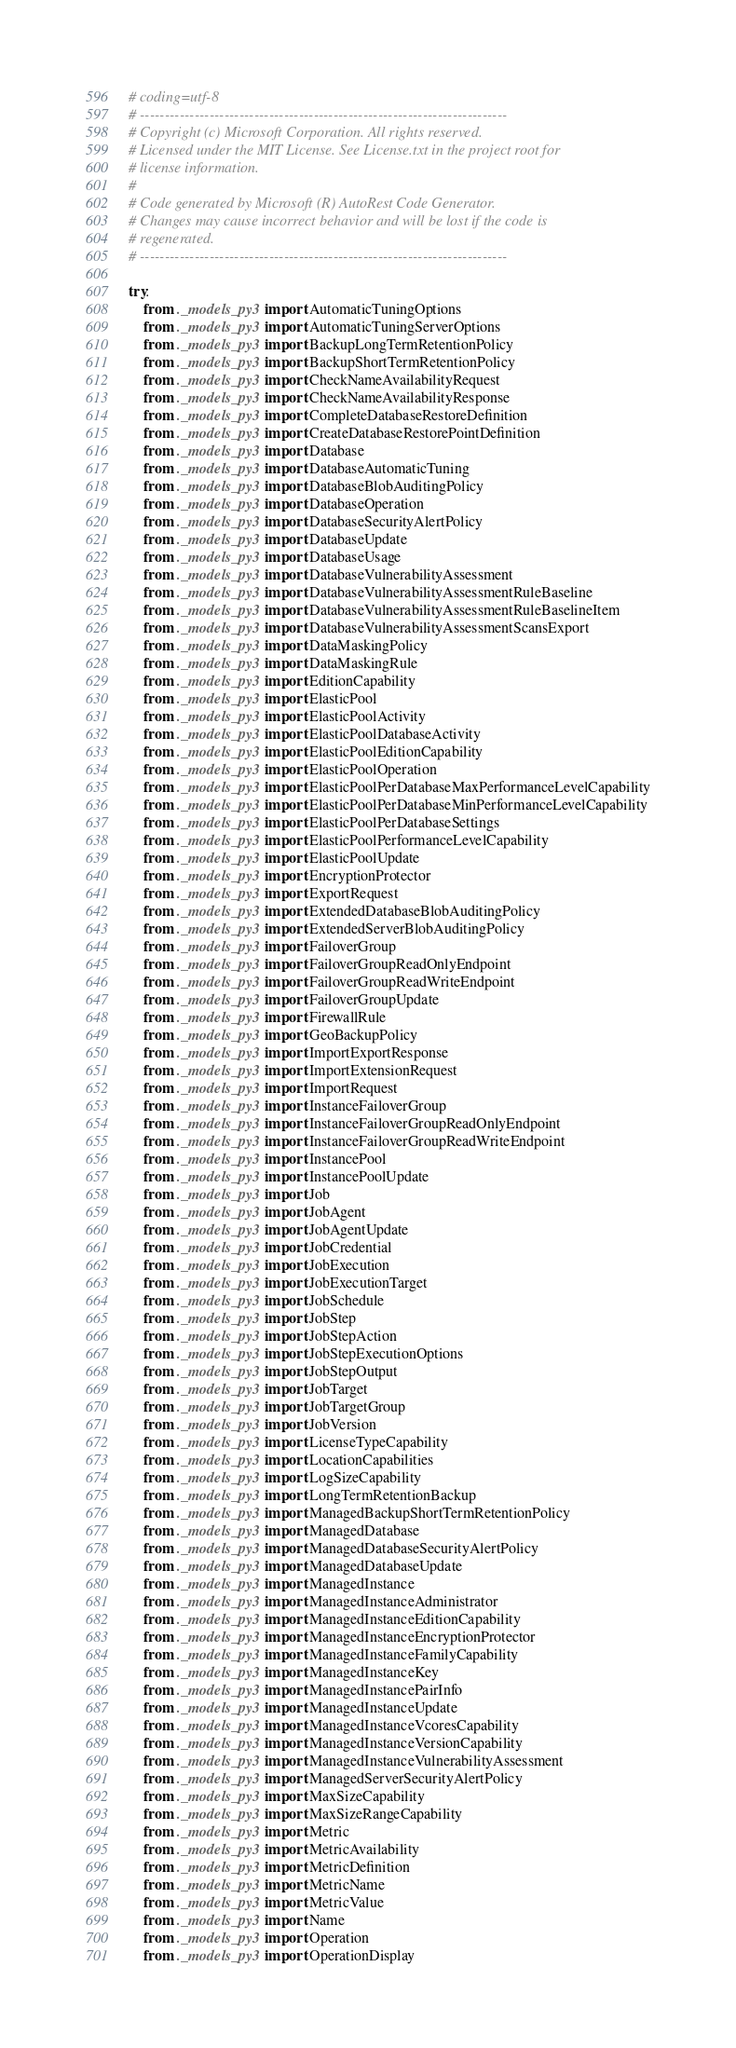<code> <loc_0><loc_0><loc_500><loc_500><_Python_># coding=utf-8
# --------------------------------------------------------------------------
# Copyright (c) Microsoft Corporation. All rights reserved.
# Licensed under the MIT License. See License.txt in the project root for
# license information.
#
# Code generated by Microsoft (R) AutoRest Code Generator.
# Changes may cause incorrect behavior and will be lost if the code is
# regenerated.
# --------------------------------------------------------------------------

try:
    from ._models_py3 import AutomaticTuningOptions
    from ._models_py3 import AutomaticTuningServerOptions
    from ._models_py3 import BackupLongTermRetentionPolicy
    from ._models_py3 import BackupShortTermRetentionPolicy
    from ._models_py3 import CheckNameAvailabilityRequest
    from ._models_py3 import CheckNameAvailabilityResponse
    from ._models_py3 import CompleteDatabaseRestoreDefinition
    from ._models_py3 import CreateDatabaseRestorePointDefinition
    from ._models_py3 import Database
    from ._models_py3 import DatabaseAutomaticTuning
    from ._models_py3 import DatabaseBlobAuditingPolicy
    from ._models_py3 import DatabaseOperation
    from ._models_py3 import DatabaseSecurityAlertPolicy
    from ._models_py3 import DatabaseUpdate
    from ._models_py3 import DatabaseUsage
    from ._models_py3 import DatabaseVulnerabilityAssessment
    from ._models_py3 import DatabaseVulnerabilityAssessmentRuleBaseline
    from ._models_py3 import DatabaseVulnerabilityAssessmentRuleBaselineItem
    from ._models_py3 import DatabaseVulnerabilityAssessmentScansExport
    from ._models_py3 import DataMaskingPolicy
    from ._models_py3 import DataMaskingRule
    from ._models_py3 import EditionCapability
    from ._models_py3 import ElasticPool
    from ._models_py3 import ElasticPoolActivity
    from ._models_py3 import ElasticPoolDatabaseActivity
    from ._models_py3 import ElasticPoolEditionCapability
    from ._models_py3 import ElasticPoolOperation
    from ._models_py3 import ElasticPoolPerDatabaseMaxPerformanceLevelCapability
    from ._models_py3 import ElasticPoolPerDatabaseMinPerformanceLevelCapability
    from ._models_py3 import ElasticPoolPerDatabaseSettings
    from ._models_py3 import ElasticPoolPerformanceLevelCapability
    from ._models_py3 import ElasticPoolUpdate
    from ._models_py3 import EncryptionProtector
    from ._models_py3 import ExportRequest
    from ._models_py3 import ExtendedDatabaseBlobAuditingPolicy
    from ._models_py3 import ExtendedServerBlobAuditingPolicy
    from ._models_py3 import FailoverGroup
    from ._models_py3 import FailoverGroupReadOnlyEndpoint
    from ._models_py3 import FailoverGroupReadWriteEndpoint
    from ._models_py3 import FailoverGroupUpdate
    from ._models_py3 import FirewallRule
    from ._models_py3 import GeoBackupPolicy
    from ._models_py3 import ImportExportResponse
    from ._models_py3 import ImportExtensionRequest
    from ._models_py3 import ImportRequest
    from ._models_py3 import InstanceFailoverGroup
    from ._models_py3 import InstanceFailoverGroupReadOnlyEndpoint
    from ._models_py3 import InstanceFailoverGroupReadWriteEndpoint
    from ._models_py3 import InstancePool
    from ._models_py3 import InstancePoolUpdate
    from ._models_py3 import Job
    from ._models_py3 import JobAgent
    from ._models_py3 import JobAgentUpdate
    from ._models_py3 import JobCredential
    from ._models_py3 import JobExecution
    from ._models_py3 import JobExecutionTarget
    from ._models_py3 import JobSchedule
    from ._models_py3 import JobStep
    from ._models_py3 import JobStepAction
    from ._models_py3 import JobStepExecutionOptions
    from ._models_py3 import JobStepOutput
    from ._models_py3 import JobTarget
    from ._models_py3 import JobTargetGroup
    from ._models_py3 import JobVersion
    from ._models_py3 import LicenseTypeCapability
    from ._models_py3 import LocationCapabilities
    from ._models_py3 import LogSizeCapability
    from ._models_py3 import LongTermRetentionBackup
    from ._models_py3 import ManagedBackupShortTermRetentionPolicy
    from ._models_py3 import ManagedDatabase
    from ._models_py3 import ManagedDatabaseSecurityAlertPolicy
    from ._models_py3 import ManagedDatabaseUpdate
    from ._models_py3 import ManagedInstance
    from ._models_py3 import ManagedInstanceAdministrator
    from ._models_py3 import ManagedInstanceEditionCapability
    from ._models_py3 import ManagedInstanceEncryptionProtector
    from ._models_py3 import ManagedInstanceFamilyCapability
    from ._models_py3 import ManagedInstanceKey
    from ._models_py3 import ManagedInstancePairInfo
    from ._models_py3 import ManagedInstanceUpdate
    from ._models_py3 import ManagedInstanceVcoresCapability
    from ._models_py3 import ManagedInstanceVersionCapability
    from ._models_py3 import ManagedInstanceVulnerabilityAssessment
    from ._models_py3 import ManagedServerSecurityAlertPolicy
    from ._models_py3 import MaxSizeCapability
    from ._models_py3 import MaxSizeRangeCapability
    from ._models_py3 import Metric
    from ._models_py3 import MetricAvailability
    from ._models_py3 import MetricDefinition
    from ._models_py3 import MetricName
    from ._models_py3 import MetricValue
    from ._models_py3 import Name
    from ._models_py3 import Operation
    from ._models_py3 import OperationDisplay</code> 